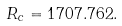Convert formula to latex. <formula><loc_0><loc_0><loc_500><loc_500>R _ { c } = 1 7 0 7 . 7 6 2 .</formula> 